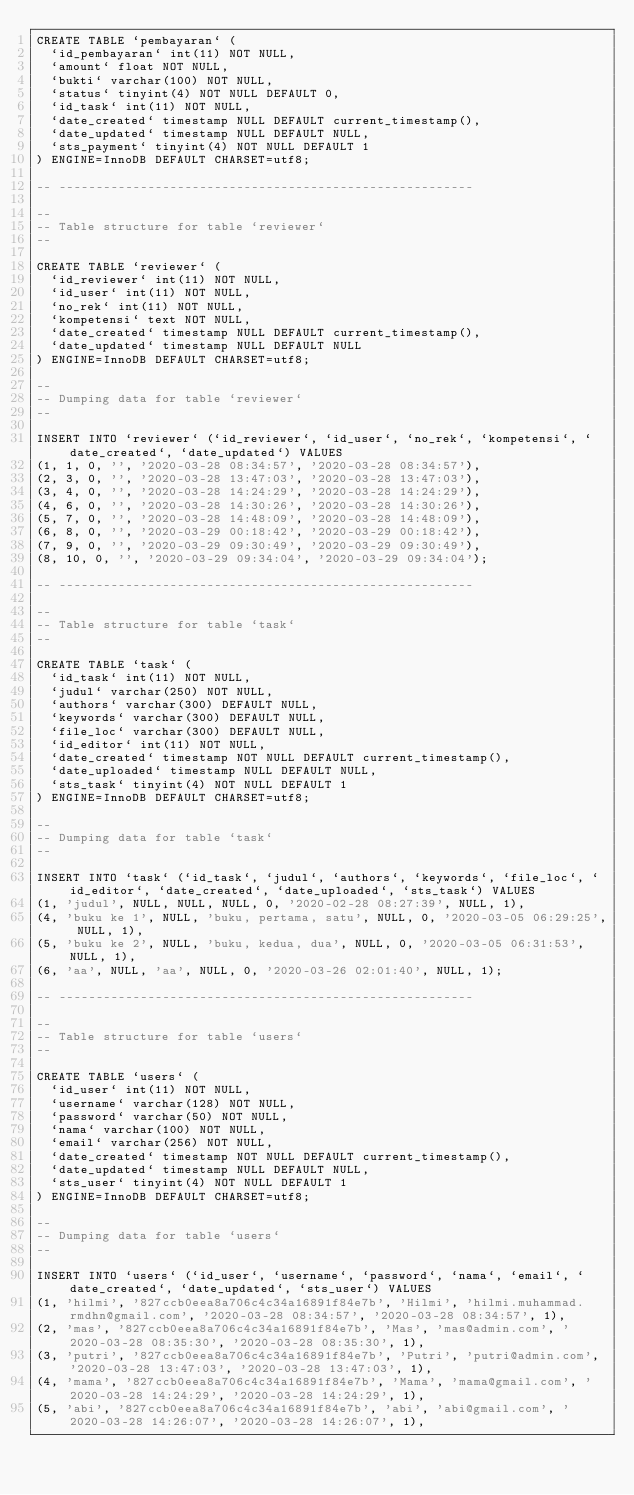<code> <loc_0><loc_0><loc_500><loc_500><_SQL_>CREATE TABLE `pembayaran` (
  `id_pembayaran` int(11) NOT NULL,
  `amount` float NOT NULL,
  `bukti` varchar(100) NOT NULL,
  `status` tinyint(4) NOT NULL DEFAULT 0,
  `id_task` int(11) NOT NULL,
  `date_created` timestamp NULL DEFAULT current_timestamp(),
  `date_updated` timestamp NULL DEFAULT NULL,
  `sts_payment` tinyint(4) NOT NULL DEFAULT 1
) ENGINE=InnoDB DEFAULT CHARSET=utf8;

-- --------------------------------------------------------

--
-- Table structure for table `reviewer`
--

CREATE TABLE `reviewer` (
  `id_reviewer` int(11) NOT NULL,
  `id_user` int(11) NOT NULL,
  `no_rek` int(11) NOT NULL,
  `kompetensi` text NOT NULL,
  `date_created` timestamp NULL DEFAULT current_timestamp(),
  `date_updated` timestamp NULL DEFAULT NULL
) ENGINE=InnoDB DEFAULT CHARSET=utf8;

--
-- Dumping data for table `reviewer`
--

INSERT INTO `reviewer` (`id_reviewer`, `id_user`, `no_rek`, `kompetensi`, `date_created`, `date_updated`) VALUES
(1, 1, 0, '', '2020-03-28 08:34:57', '2020-03-28 08:34:57'),
(2, 3, 0, '', '2020-03-28 13:47:03', '2020-03-28 13:47:03'),
(3, 4, 0, '', '2020-03-28 14:24:29', '2020-03-28 14:24:29'),
(4, 6, 0, '', '2020-03-28 14:30:26', '2020-03-28 14:30:26'),
(5, 7, 0, '', '2020-03-28 14:48:09', '2020-03-28 14:48:09'),
(6, 8, 0, '', '2020-03-29 00:18:42', '2020-03-29 00:18:42'),
(7, 9, 0, '', '2020-03-29 09:30:49', '2020-03-29 09:30:49'),
(8, 10, 0, '', '2020-03-29 09:34:04', '2020-03-29 09:34:04');

-- --------------------------------------------------------

--
-- Table structure for table `task`
--

CREATE TABLE `task` (
  `id_task` int(11) NOT NULL,
  `judul` varchar(250) NOT NULL,
  `authors` varchar(300) DEFAULT NULL,
  `keywords` varchar(300) DEFAULT NULL,
  `file_loc` varchar(300) DEFAULT NULL,
  `id_editor` int(11) NOT NULL,
  `date_created` timestamp NOT NULL DEFAULT current_timestamp(),
  `date_uploaded` timestamp NULL DEFAULT NULL,
  `sts_task` tinyint(4) NOT NULL DEFAULT 1
) ENGINE=InnoDB DEFAULT CHARSET=utf8;

--
-- Dumping data for table `task`
--

INSERT INTO `task` (`id_task`, `judul`, `authors`, `keywords`, `file_loc`, `id_editor`, `date_created`, `date_uploaded`, `sts_task`) VALUES
(1, 'judul', NULL, NULL, NULL, 0, '2020-02-28 08:27:39', NULL, 1),
(4, 'buku ke 1', NULL, 'buku, pertama, satu', NULL, 0, '2020-03-05 06:29:25', NULL, 1),
(5, 'buku ke 2', NULL, 'buku, kedua, dua', NULL, 0, '2020-03-05 06:31:53', NULL, 1),
(6, 'aa', NULL, 'aa', NULL, 0, '2020-03-26 02:01:40', NULL, 1);

-- --------------------------------------------------------

--
-- Table structure for table `users`
--

CREATE TABLE `users` (
  `id_user` int(11) NOT NULL,
  `username` varchar(128) NOT NULL,
  `password` varchar(50) NOT NULL,
  `nama` varchar(100) NOT NULL,
  `email` varchar(256) NOT NULL,
  `date_created` timestamp NOT NULL DEFAULT current_timestamp(),
  `date_updated` timestamp NULL DEFAULT NULL,
  `sts_user` tinyint(4) NOT NULL DEFAULT 1
) ENGINE=InnoDB DEFAULT CHARSET=utf8;

--
-- Dumping data for table `users`
--

INSERT INTO `users` (`id_user`, `username`, `password`, `nama`, `email`, `date_created`, `date_updated`, `sts_user`) VALUES
(1, 'hilmi', '827ccb0eea8a706c4c34a16891f84e7b', 'Hilmi', 'hilmi.muhammad.rmdhn@gmail.com', '2020-03-28 08:34:57', '2020-03-28 08:34:57', 1),
(2, 'mas', '827ccb0eea8a706c4c34a16891f84e7b', 'Mas', 'mas@admin.com', '2020-03-28 08:35:30', '2020-03-28 08:35:30', 1),
(3, 'putri', '827ccb0eea8a706c4c34a16891f84e7b', 'Putri', 'putri@admin.com', '2020-03-28 13:47:03', '2020-03-28 13:47:03', 1),
(4, 'mama', '827ccb0eea8a706c4c34a16891f84e7b', 'Mama', 'mama@gmail.com', '2020-03-28 14:24:29', '2020-03-28 14:24:29', 1),
(5, 'abi', '827ccb0eea8a706c4c34a16891f84e7b', 'abi', 'abi@gmail.com', '2020-03-28 14:26:07', '2020-03-28 14:26:07', 1),</code> 